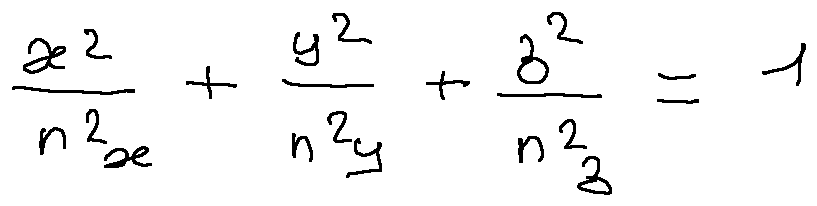<formula> <loc_0><loc_0><loc_500><loc_500>\frac { x ^ { 2 } } { n _ { x } ^ { 2 } } + \frac { y ^ { 2 } } { n _ { y } ^ { 2 } } + \frac { z ^ { 2 } } { n _ { z } ^ { 2 } } = 1</formula> 